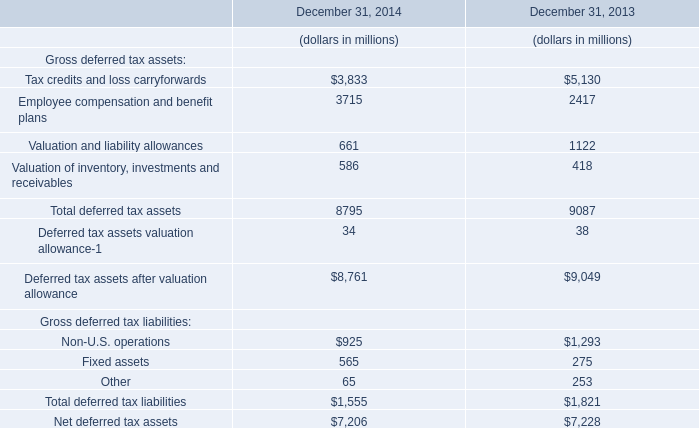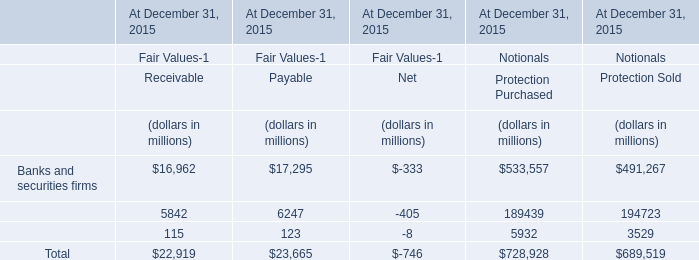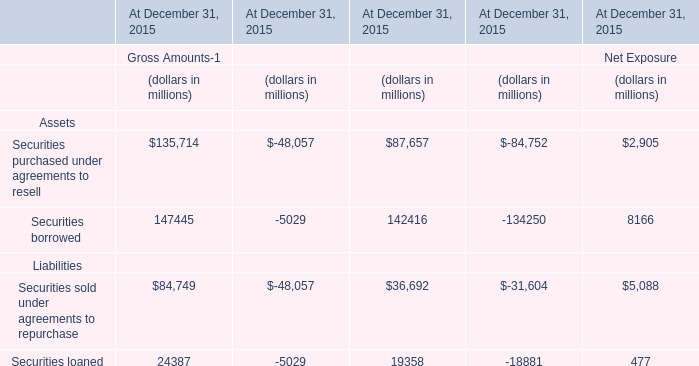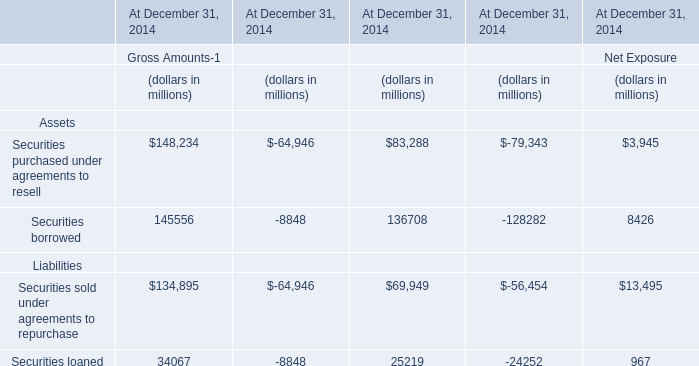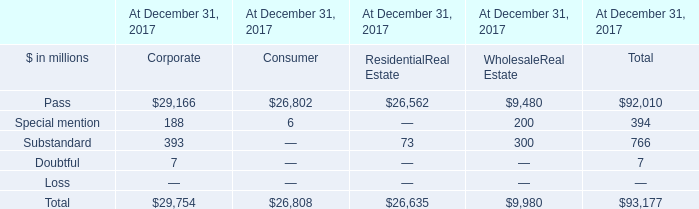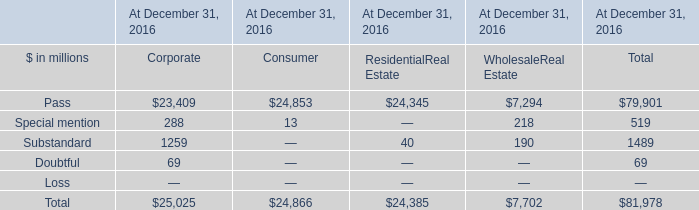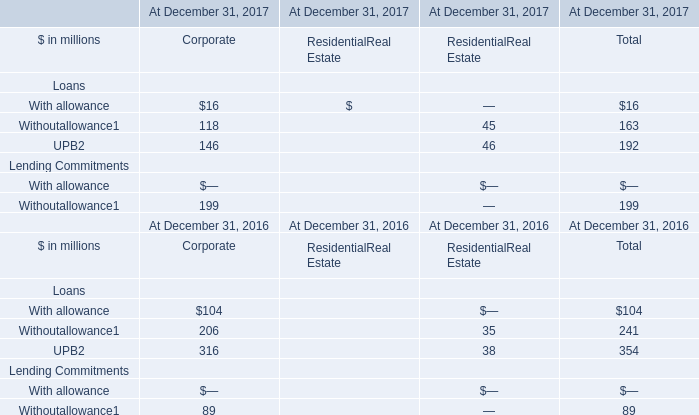What was the total amount of Corporate greater than 20 in 2017? (in million) 
Computations: ((118 + 146) + 199)
Answer: 463.0. 